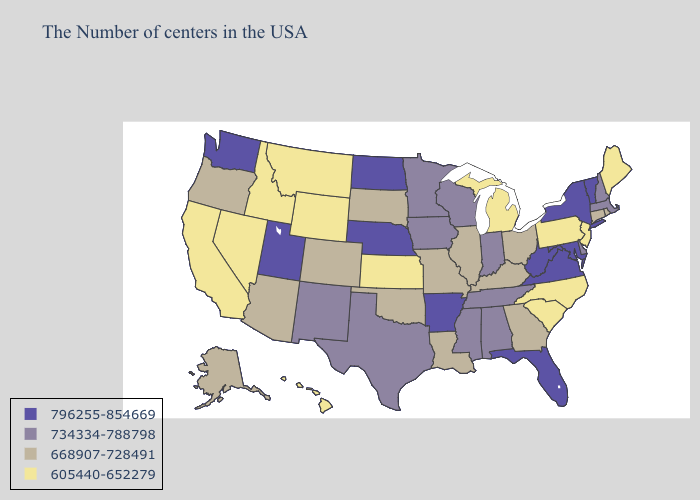What is the lowest value in the West?
Answer briefly. 605440-652279. What is the lowest value in states that border Illinois?
Answer briefly. 668907-728491. Name the states that have a value in the range 734334-788798?
Give a very brief answer. Massachusetts, New Hampshire, Delaware, Indiana, Alabama, Tennessee, Wisconsin, Mississippi, Minnesota, Iowa, Texas, New Mexico. Which states have the lowest value in the USA?
Keep it brief. Maine, New Jersey, Pennsylvania, North Carolina, South Carolina, Michigan, Kansas, Wyoming, Montana, Idaho, Nevada, California, Hawaii. Does New York have the highest value in the USA?
Concise answer only. Yes. What is the highest value in the USA?
Concise answer only. 796255-854669. What is the value of Washington?
Be succinct. 796255-854669. Name the states that have a value in the range 605440-652279?
Keep it brief. Maine, New Jersey, Pennsylvania, North Carolina, South Carolina, Michigan, Kansas, Wyoming, Montana, Idaho, Nevada, California, Hawaii. Which states have the lowest value in the South?
Give a very brief answer. North Carolina, South Carolina. What is the lowest value in states that border Louisiana?
Answer briefly. 734334-788798. Among the states that border Rhode Island , does Connecticut have the lowest value?
Write a very short answer. Yes. What is the value of Massachusetts?
Short answer required. 734334-788798. Does New Hampshire have the same value as Tennessee?
Give a very brief answer. Yes. Does New York have a higher value than Wyoming?
Answer briefly. Yes. 